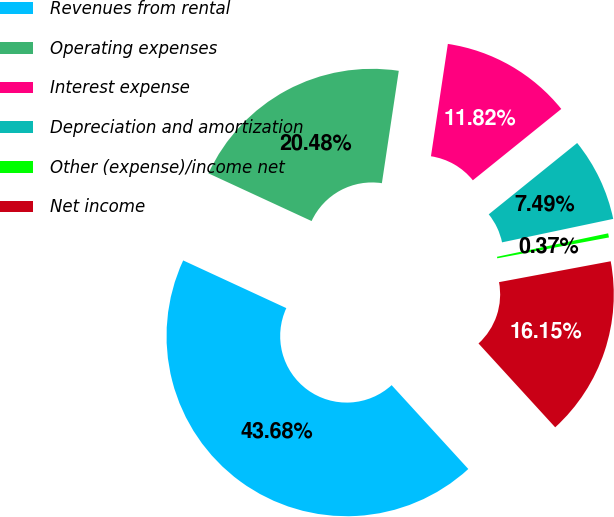<chart> <loc_0><loc_0><loc_500><loc_500><pie_chart><fcel>Revenues from rental<fcel>Operating expenses<fcel>Interest expense<fcel>Depreciation and amortization<fcel>Other (expense)/income net<fcel>Net income<nl><fcel>43.68%<fcel>20.48%<fcel>11.82%<fcel>7.49%<fcel>0.37%<fcel>16.15%<nl></chart> 